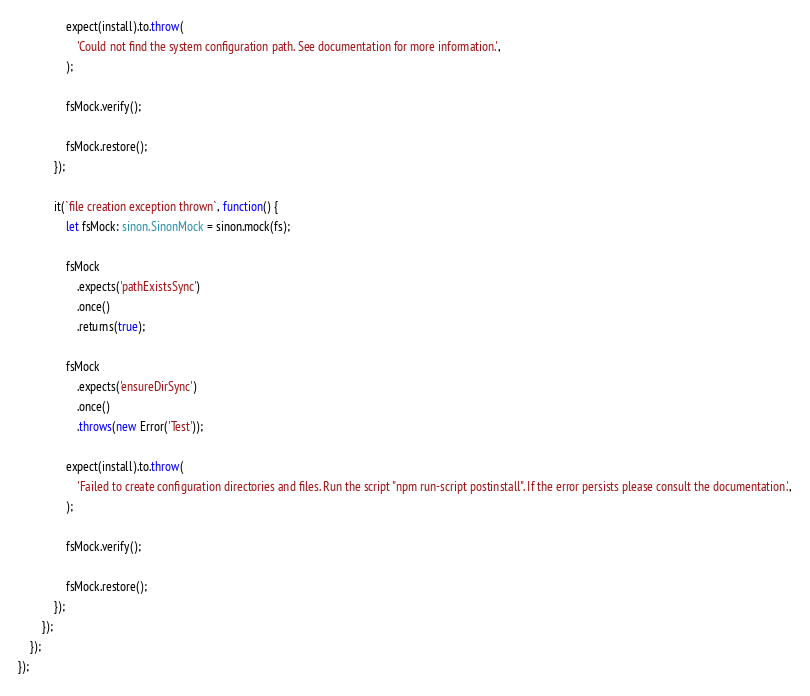Convert code to text. <code><loc_0><loc_0><loc_500><loc_500><_TypeScript_>
                expect(install).to.throw(
                    'Could not find the system configuration path. See documentation for more information.',
                );

                fsMock.verify();

                fsMock.restore();
            });

            it(`file creation exception thrown`, function() {
                let fsMock: sinon.SinonMock = sinon.mock(fs);

                fsMock
                    .expects('pathExistsSync')
                    .once()
                    .returns(true);

                fsMock
                    .expects('ensureDirSync')
                    .once()
                    .throws(new Error('Test'));

                expect(install).to.throw(
                    'Failed to create configuration directories and files. Run the script "npm run-script postinstall". If the error persists please consult the documentation.',
                );

                fsMock.verify();

                fsMock.restore();
            });
        });
    });
});
</code> 